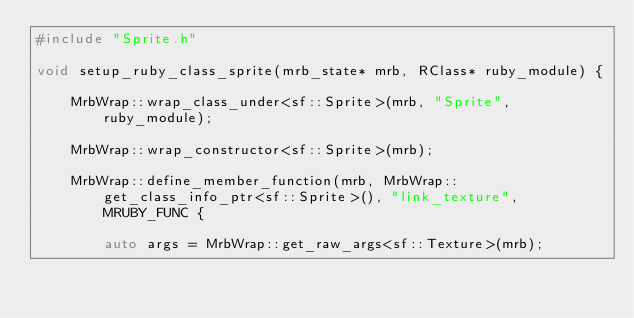Convert code to text. <code><loc_0><loc_0><loc_500><loc_500><_C++_>#include "Sprite.h"

void setup_ruby_class_sprite(mrb_state* mrb, RClass* ruby_module) {

	MrbWrap::wrap_class_under<sf::Sprite>(mrb, "Sprite", ruby_module);

	MrbWrap::wrap_constructor<sf::Sprite>(mrb);

	MrbWrap::define_member_function(mrb, MrbWrap::get_class_info_ptr<sf::Sprite>(), "link_texture", MRUBY_FUNC {

		auto args = MrbWrap::get_raw_args<sf::Texture>(mrb);</code> 